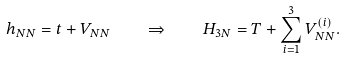Convert formula to latex. <formula><loc_0><loc_0><loc_500><loc_500>h _ { N N } = t + V _ { N N } \quad \Rightarrow \quad H _ { 3 N } = T + \sum _ { i = 1 } ^ { 3 } V _ { N N } ^ { ( i ) } .</formula> 